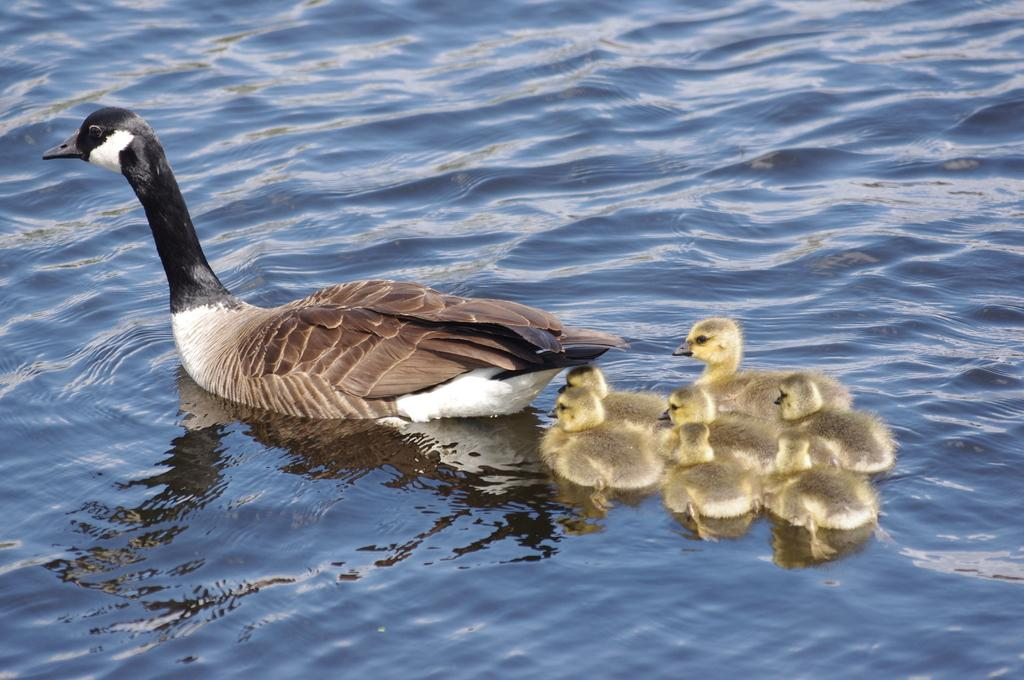What type of animal can be seen in the image? There is a duck in the image. Are there any baby ducks in the image? Yes, there are ducklings in the image. Where are the duck and ducklings located? The duck and ducklings are in the water. What is visible in the image besides the ducks? There is water visible in the image. What type of engine is powering the duck in the image? There is no engine present in the image; the duck and ducklings are swimming in the water. 